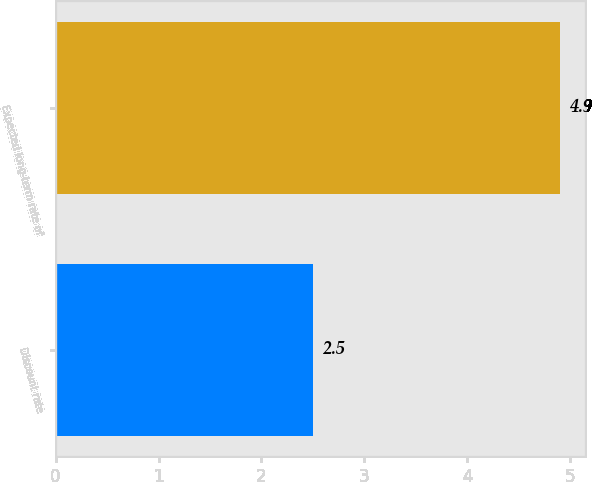Convert chart to OTSL. <chart><loc_0><loc_0><loc_500><loc_500><bar_chart><fcel>Discount rate<fcel>Expected long-term rate of<nl><fcel>2.5<fcel>4.9<nl></chart> 